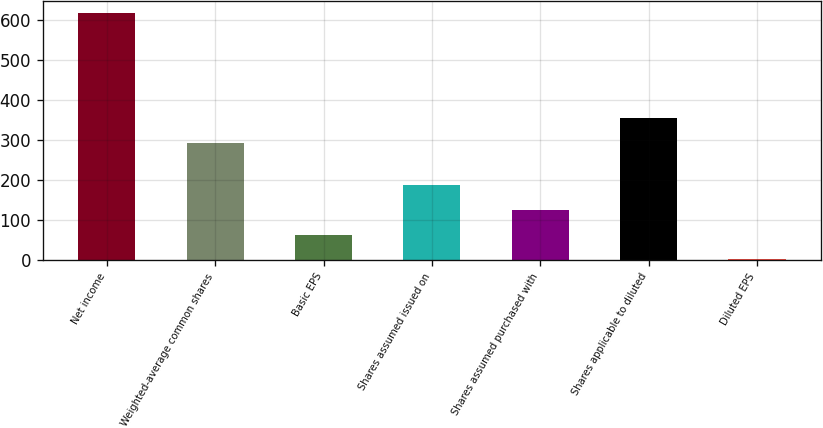Convert chart to OTSL. <chart><loc_0><loc_0><loc_500><loc_500><bar_chart><fcel>Net income<fcel>Weighted-average common shares<fcel>Basic EPS<fcel>Shares assumed issued on<fcel>Shares assumed purchased with<fcel>Shares applicable to diluted<fcel>Diluted EPS<nl><fcel>617<fcel>293<fcel>63.52<fcel>186.52<fcel>125.02<fcel>354.5<fcel>2.02<nl></chart> 